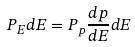<formula> <loc_0><loc_0><loc_500><loc_500>P _ { E } d E = P _ { p } \frac { d p } { d E } d E</formula> 